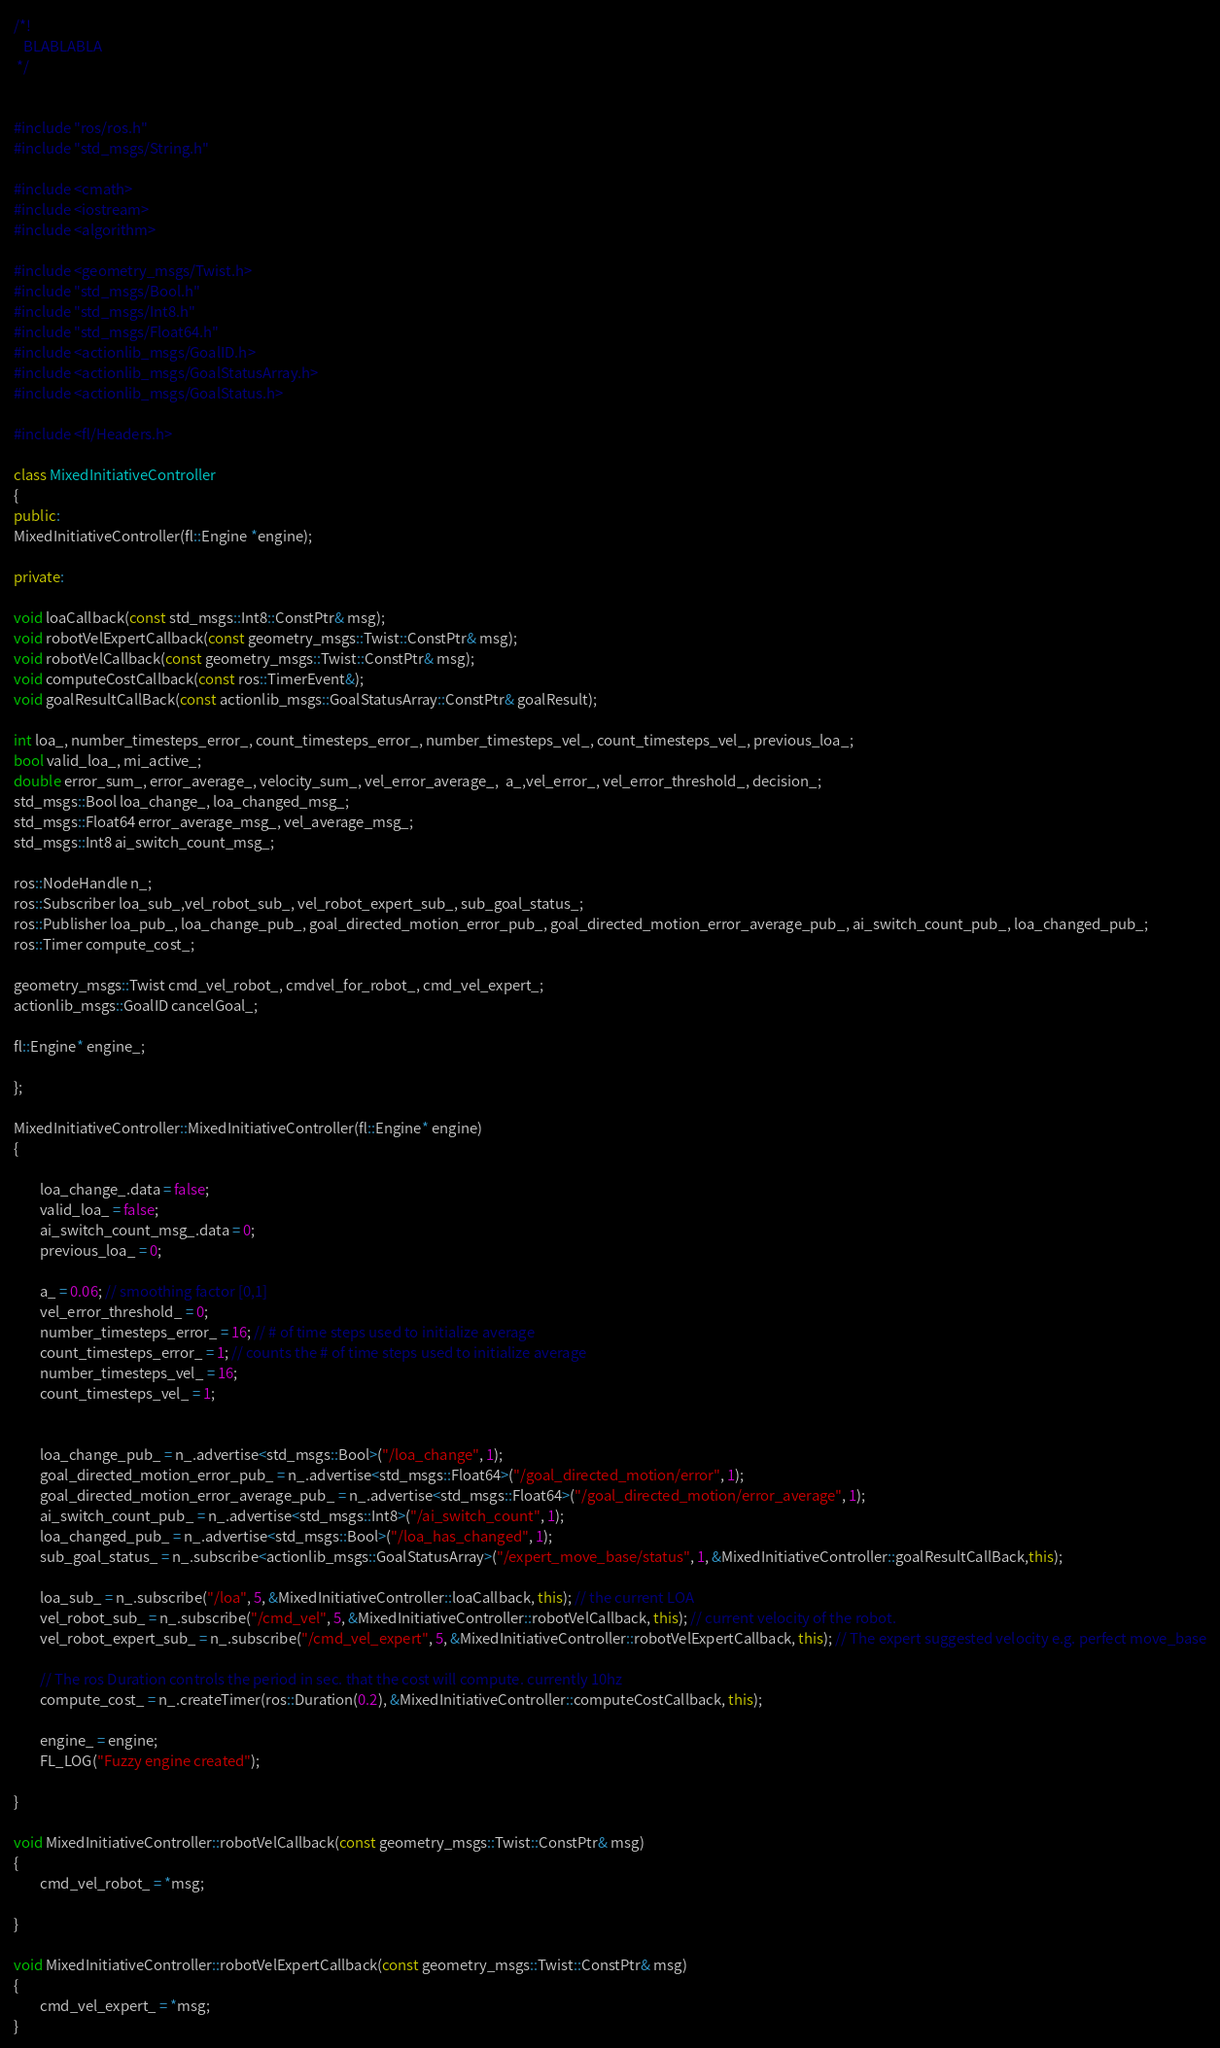Convert code to text. <code><loc_0><loc_0><loc_500><loc_500><_C++_>
/*!
   BLABLABLA
 */


#include "ros/ros.h"
#include "std_msgs/String.h"

#include <cmath>
#include <iostream>
#include <algorithm>

#include <geometry_msgs/Twist.h>
#include "std_msgs/Bool.h"
#include "std_msgs/Int8.h"
#include "std_msgs/Float64.h"
#include <actionlib_msgs/GoalID.h>
#include <actionlib_msgs/GoalStatusArray.h>
#include <actionlib_msgs/GoalStatus.h>

#include <fl/Headers.h>

class MixedInitiativeController
{
public:
MixedInitiativeController(fl::Engine *engine);

private:

void loaCallback(const std_msgs::Int8::ConstPtr& msg);
void robotVelExpertCallback(const geometry_msgs::Twist::ConstPtr& msg);
void robotVelCallback(const geometry_msgs::Twist::ConstPtr& msg);
void computeCostCallback(const ros::TimerEvent&);
void goalResultCallBack(const actionlib_msgs::GoalStatusArray::ConstPtr& goalResult);

int loa_, number_timesteps_error_, count_timesteps_error_, number_timesteps_vel_, count_timesteps_vel_, previous_loa_;
bool valid_loa_, mi_active_;
double error_sum_, error_average_, velocity_sum_, vel_error_average_,  a_,vel_error_, vel_error_threshold_, decision_;
std_msgs::Bool loa_change_, loa_changed_msg_;
std_msgs::Float64 error_average_msg_, vel_average_msg_;
std_msgs::Int8 ai_switch_count_msg_;

ros::NodeHandle n_;
ros::Subscriber loa_sub_,vel_robot_sub_, vel_robot_expert_sub_, sub_goal_status_;
ros::Publisher loa_pub_, loa_change_pub_, goal_directed_motion_error_pub_, goal_directed_motion_error_average_pub_, ai_switch_count_pub_, loa_changed_pub_;
ros::Timer compute_cost_;

geometry_msgs::Twist cmd_vel_robot_, cmdvel_for_robot_, cmd_vel_expert_;
actionlib_msgs::GoalID cancelGoal_;

fl::Engine* engine_;

};

MixedInitiativeController::MixedInitiativeController(fl::Engine* engine)
{

        loa_change_.data = false;
        valid_loa_ = false;
        ai_switch_count_msg_.data = 0;
        previous_loa_ = 0;

        a_ = 0.06; // smoothing factor [0,1]
        vel_error_threshold_ = 0;
        number_timesteps_error_ = 16; // # of time steps used to initialize average
        count_timesteps_error_ = 1; // counts the # of time steps used to initialize average
        number_timesteps_vel_ = 16;
        count_timesteps_vel_ = 1;


        loa_change_pub_ = n_.advertise<std_msgs::Bool>("/loa_change", 1);
        goal_directed_motion_error_pub_ = n_.advertise<std_msgs::Float64>("/goal_directed_motion/error", 1);
        goal_directed_motion_error_average_pub_ = n_.advertise<std_msgs::Float64>("/goal_directed_motion/error_average", 1);
        ai_switch_count_pub_ = n_.advertise<std_msgs::Int8>("/ai_switch_count", 1);
        loa_changed_pub_ = n_.advertise<std_msgs::Bool>("/loa_has_changed", 1);
        sub_goal_status_ = n_.subscribe<actionlib_msgs::GoalStatusArray>("/expert_move_base/status", 1, &MixedInitiativeController::goalResultCallBack,this);

        loa_sub_ = n_.subscribe("/loa", 5, &MixedInitiativeController::loaCallback, this); // the current LOA
        vel_robot_sub_ = n_.subscribe("/cmd_vel", 5, &MixedInitiativeController::robotVelCallback, this); // current velocity of the robot.
        vel_robot_expert_sub_ = n_.subscribe("/cmd_vel_expert", 5, &MixedInitiativeController::robotVelExpertCallback, this); // The expert suggested velocity e.g. perfect move_base

        // The ros Duration controls the period in sec. that the cost will compute. currently 10hz
        compute_cost_ = n_.createTimer(ros::Duration(0.2), &MixedInitiativeController::computeCostCallback, this);

        engine_ = engine;
        FL_LOG("Fuzzy engine created");

}

void MixedInitiativeController::robotVelCallback(const geometry_msgs::Twist::ConstPtr& msg)
{
        cmd_vel_robot_ = *msg;

}

void MixedInitiativeController::robotVelExpertCallback(const geometry_msgs::Twist::ConstPtr& msg)
{
        cmd_vel_expert_ = *msg;
}
</code> 